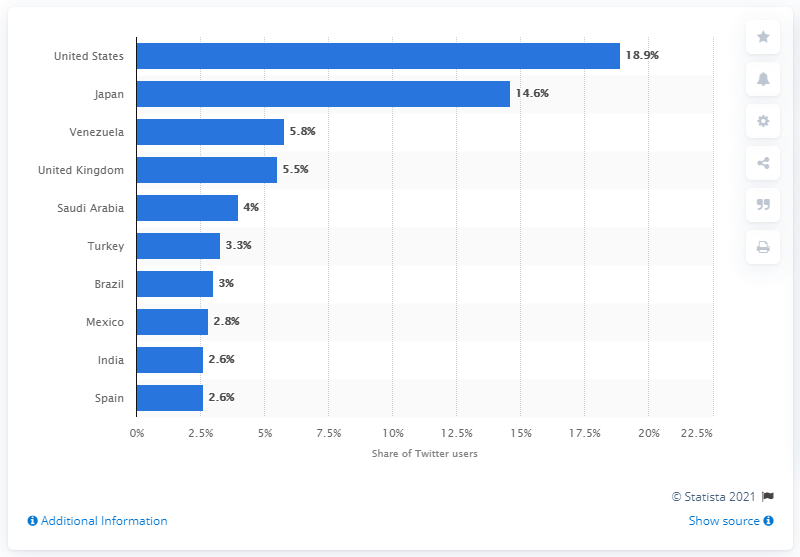Draw attention to some important aspects in this diagram. According to the data, Japan was ranked as the second country with the highest share of Twitter audience, representing 14.6% of the total audience. 